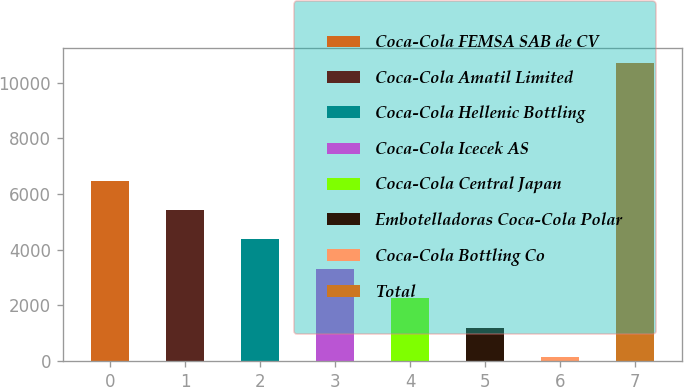<chart> <loc_0><loc_0><loc_500><loc_500><bar_chart><fcel>Coca-Cola FEMSA SAB de CV<fcel>Coca-Cola Amatil Limited<fcel>Coca-Cola Hellenic Bottling<fcel>Coca-Cola Icecek AS<fcel>Coca-Cola Central Japan<fcel>Embotelladoras Coca-Cola Polar<fcel>Coca-Cola Bottling Co<fcel>Total<nl><fcel>6473.8<fcel>5419<fcel>4364.2<fcel>3309.4<fcel>2254.6<fcel>1199.8<fcel>145<fcel>10693<nl></chart> 